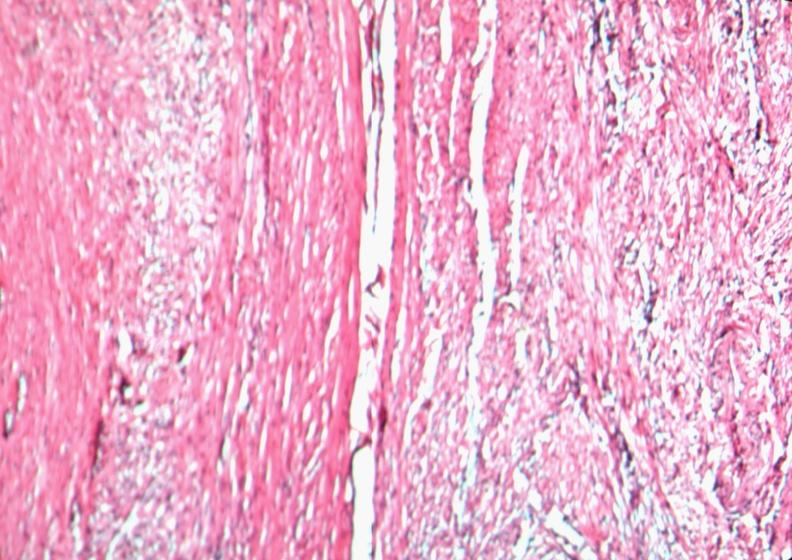s female reproductive present?
Answer the question using a single word or phrase. Yes 